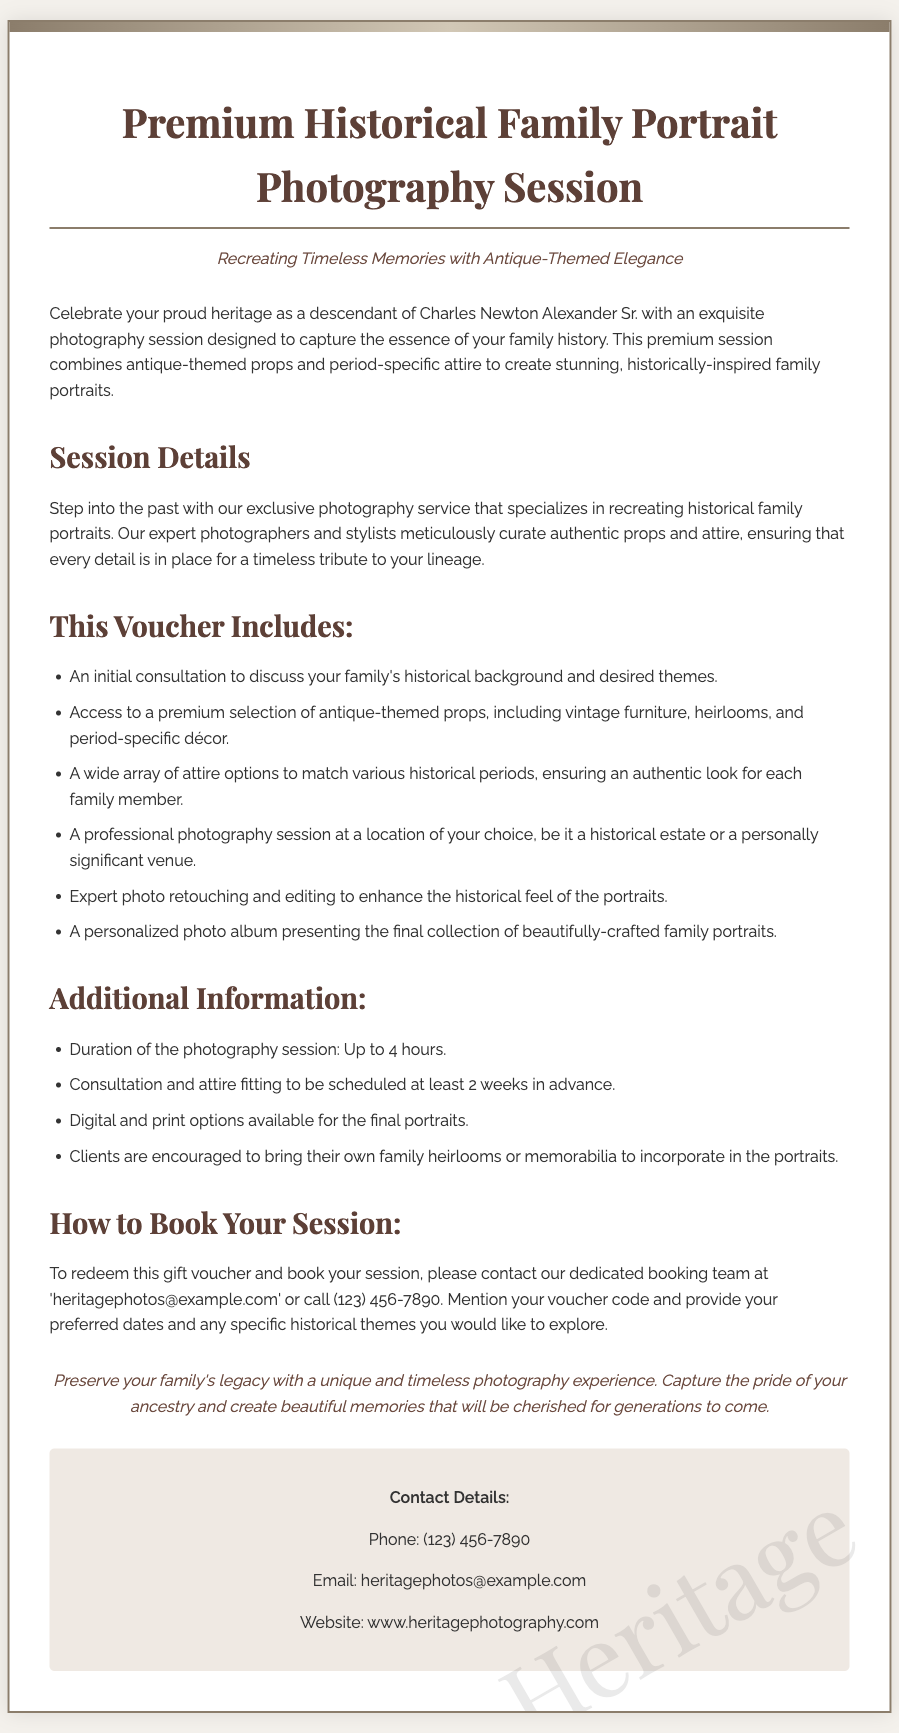what is the title of the voucher? The title of the voucher is the main heading, which introduces the photography session.
Answer: Premium Historical Family Portrait Photography Session how long is the photography session? The document specifies the duration of the photography session, providing a clear time frame for clients.
Answer: Up to 4 hours what is included in the session? The document lists various components included in the photography session, detailing the services offered.
Answer: Consultation, props, attire, photography session, photo retouching, photo album how can the session be booked? The document outlines the method to redeem the voucher and book the session, including contact details.
Answer: Contact booking team what is the contact email for bookings? The document provides a specific email address for clients to use when contacting the booking team.
Answer: heritagephotos@example.com why should clients bring their own family heirlooms? The document encourages clients to bring items that hold personal significance, showing the importance of personal connection.
Answer: To incorporate in the portraits what theme is emphasized in the session? The document mentions a key theme that the photography session aims to capture, which relates to heritage.
Answer: Historical how much notice is required for the consultation and fitting? The document specifies the lead time needed for scheduling the consultation and fitting, outlining client responsibilities.
Answer: At least 2 weeks 